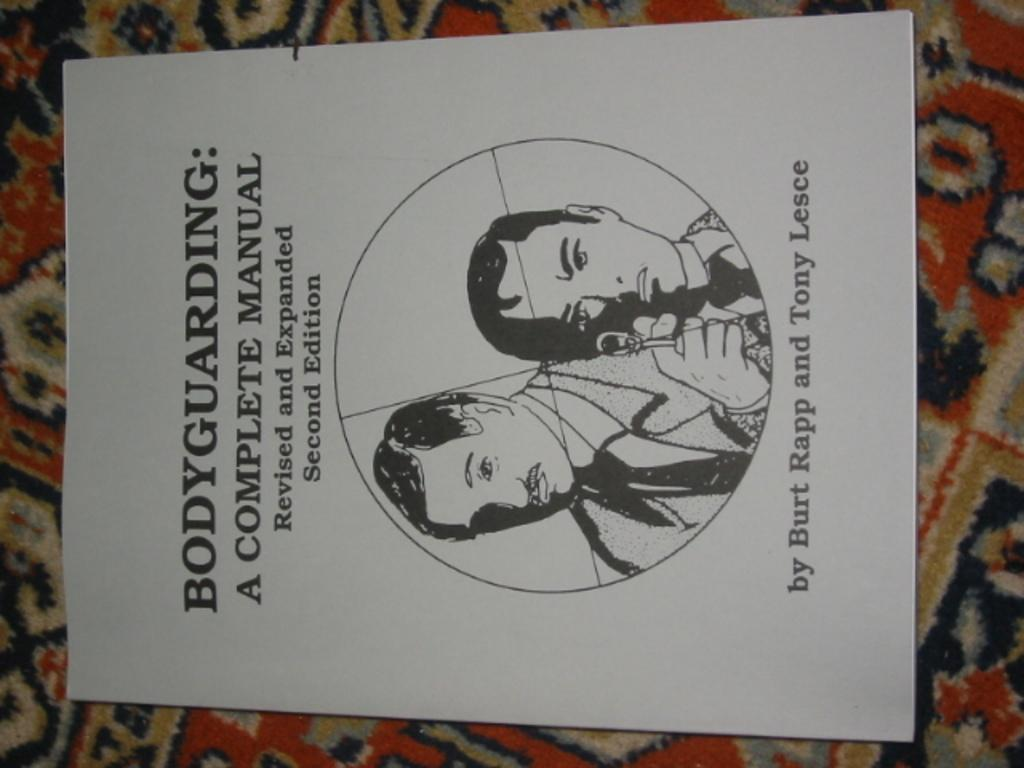<image>
Relay a brief, clear account of the picture shown. a complete manual that is for bodyguarding and is revised 